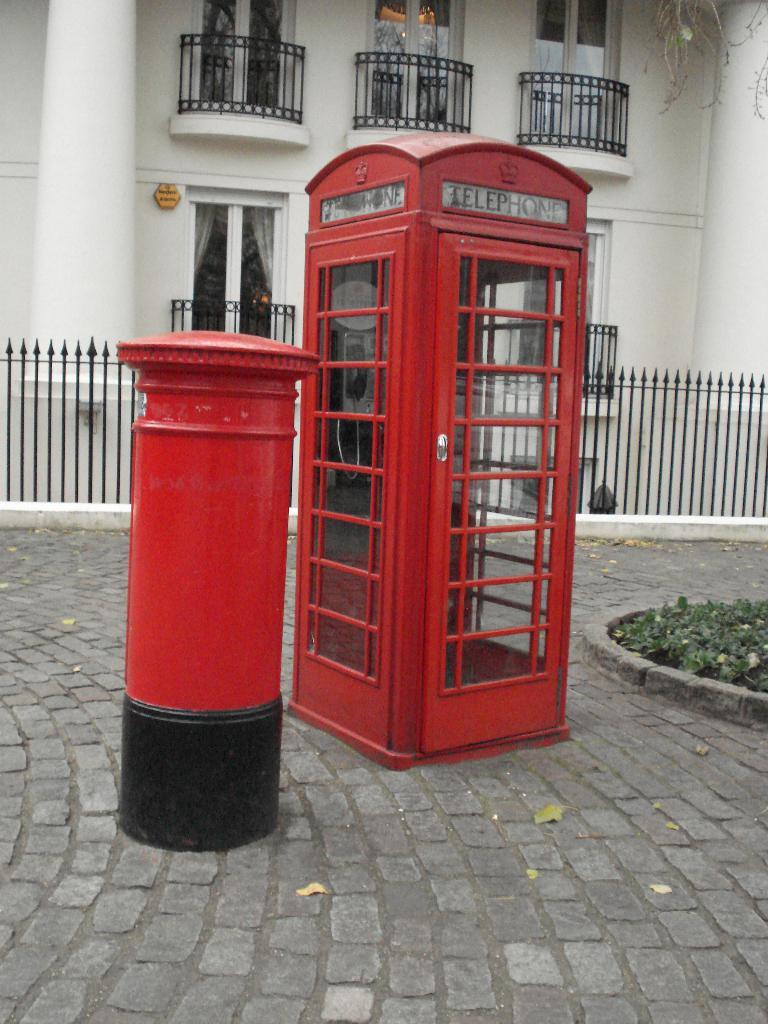What kind of booth is this?
Make the answer very short. Telephone. Is that a telephone booth or a police call box?
Give a very brief answer. Telephone. 